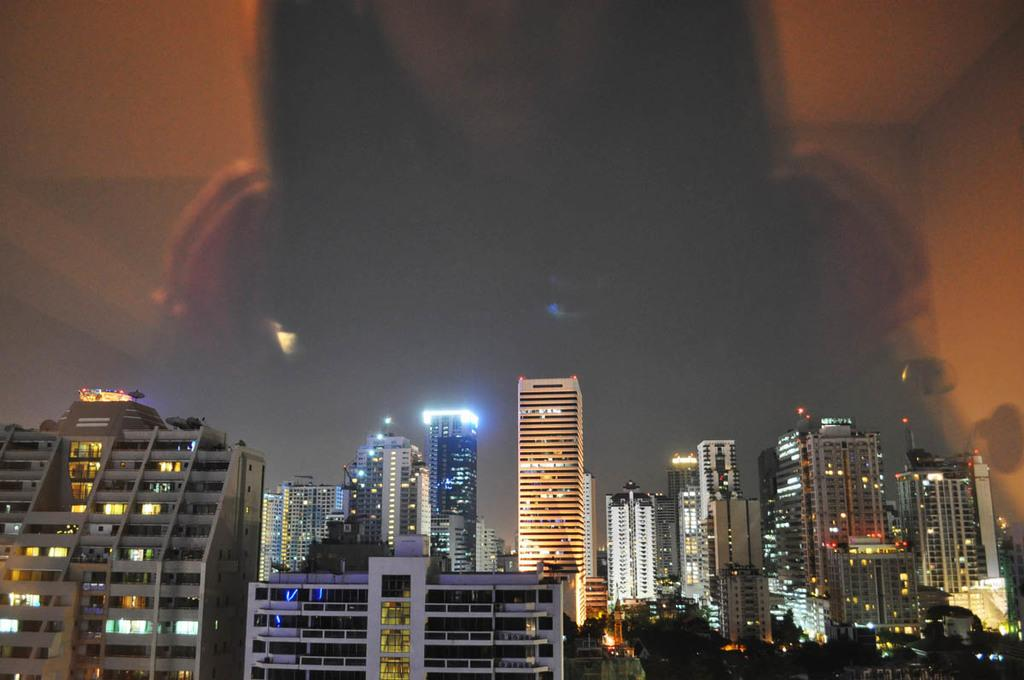What structures are visible in the image? There are buildings in the image. What feature do the buildings have? The buildings have lights. What type of agreement is being signed by the beast in the image? There is no beast present in the image, and therefore no agreement being signed. 